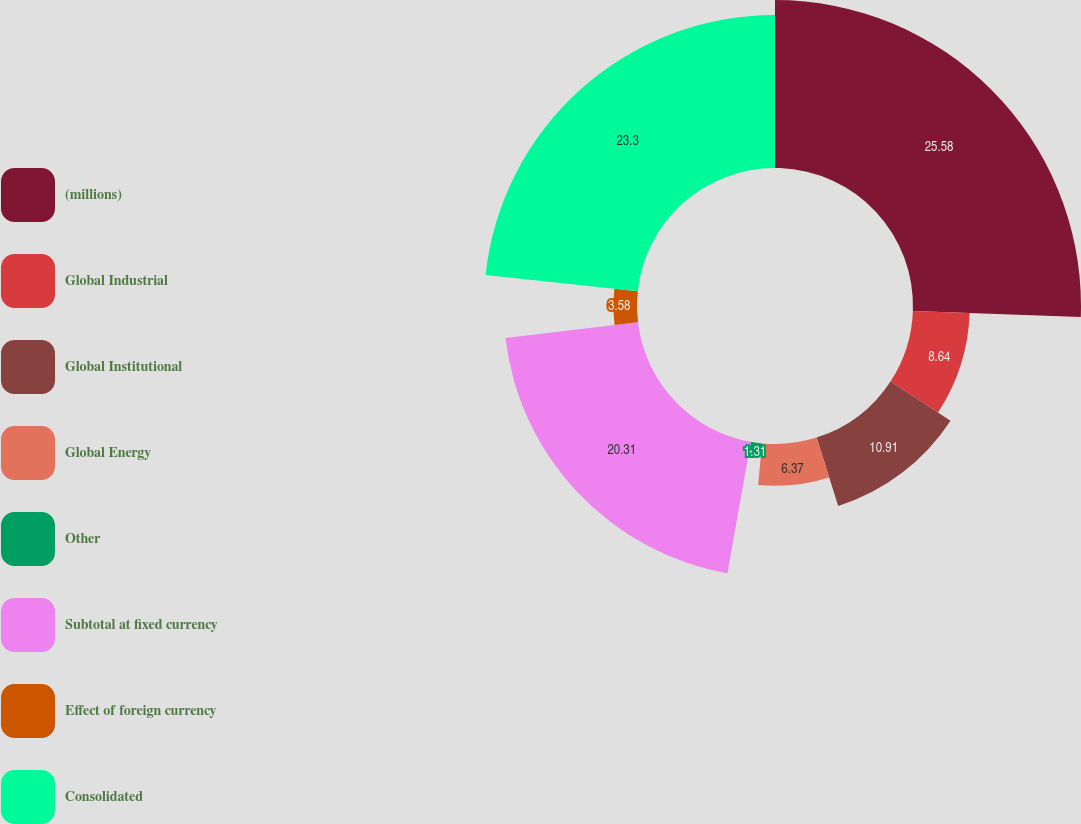<chart> <loc_0><loc_0><loc_500><loc_500><pie_chart><fcel>(millions)<fcel>Global Industrial<fcel>Global Institutional<fcel>Global Energy<fcel>Other<fcel>Subtotal at fixed currency<fcel>Effect of foreign currency<fcel>Consolidated<nl><fcel>25.57%<fcel>8.64%<fcel>10.91%<fcel>6.37%<fcel>1.31%<fcel>20.31%<fcel>3.58%<fcel>23.3%<nl></chart> 